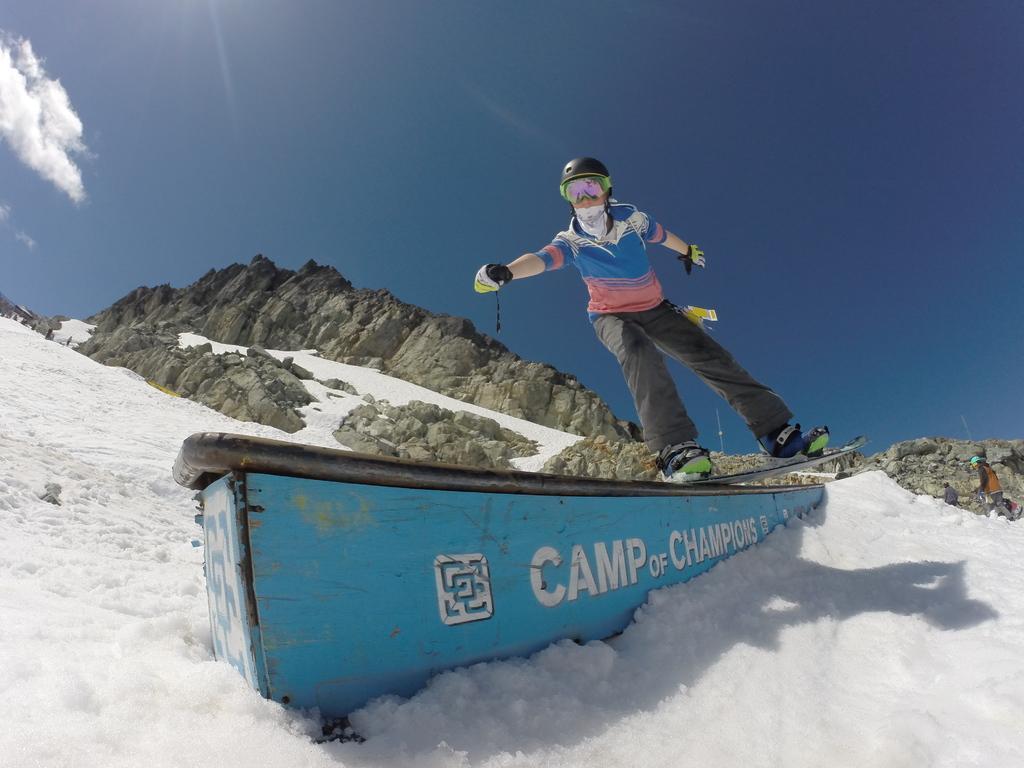Can you describe this image briefly? In this image I can see some snow on the ground which is white in color and on it I can see a blue and black colored object. On the object I can see a person wearing dress, gloves, helmet and ski board is skiing. In the background I can see few huge rocks which are cream and black in color, few persons standing in the sky. 